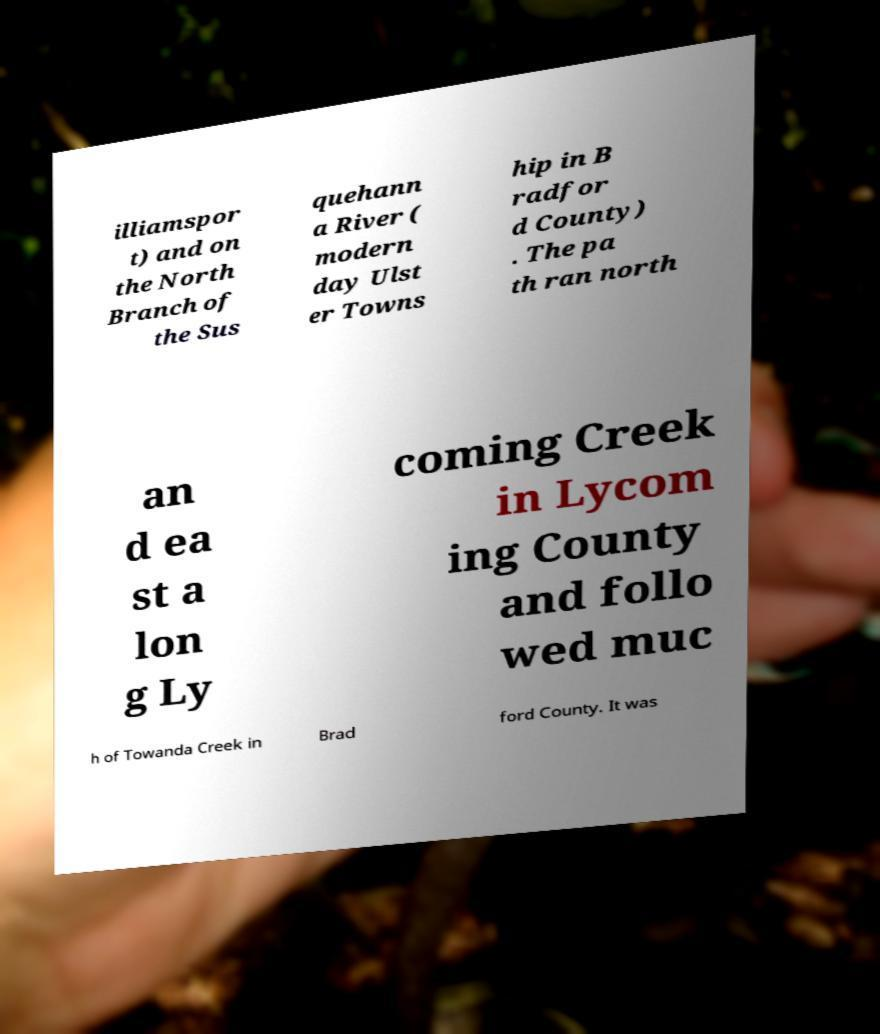Can you accurately transcribe the text from the provided image for me? illiamspor t) and on the North Branch of the Sus quehann a River ( modern day Ulst er Towns hip in B radfor d County) . The pa th ran north an d ea st a lon g Ly coming Creek in Lycom ing County and follo wed muc h of Towanda Creek in Brad ford County. It was 